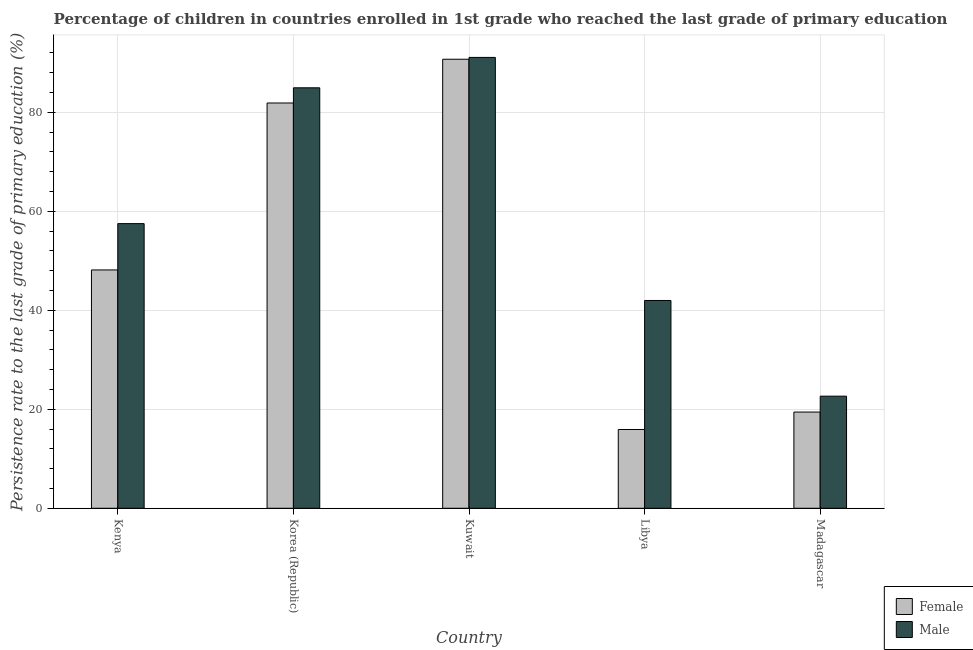Are the number of bars on each tick of the X-axis equal?
Your answer should be very brief. Yes. How many bars are there on the 2nd tick from the left?
Offer a very short reply. 2. What is the label of the 4th group of bars from the left?
Provide a succinct answer. Libya. What is the persistence rate of male students in Libya?
Provide a succinct answer. 41.99. Across all countries, what is the maximum persistence rate of female students?
Keep it short and to the point. 90.74. Across all countries, what is the minimum persistence rate of male students?
Ensure brevity in your answer.  22.65. In which country was the persistence rate of female students maximum?
Offer a terse response. Kuwait. In which country was the persistence rate of male students minimum?
Your answer should be compact. Madagascar. What is the total persistence rate of female students in the graph?
Offer a very short reply. 256.15. What is the difference between the persistence rate of female students in Kenya and that in Korea (Republic)?
Your response must be concise. -33.73. What is the difference between the persistence rate of female students in Madagascar and the persistence rate of male students in Korea (Republic)?
Make the answer very short. -65.52. What is the average persistence rate of male students per country?
Make the answer very short. 59.65. What is the difference between the persistence rate of female students and persistence rate of male students in Madagascar?
Your answer should be compact. -3.21. In how many countries, is the persistence rate of female students greater than 60 %?
Your answer should be very brief. 2. What is the ratio of the persistence rate of male students in Libya to that in Madagascar?
Make the answer very short. 1.85. Is the persistence rate of female students in Korea (Republic) less than that in Madagascar?
Your response must be concise. No. Is the difference between the persistence rate of male students in Kuwait and Madagascar greater than the difference between the persistence rate of female students in Kuwait and Madagascar?
Give a very brief answer. No. What is the difference between the highest and the second highest persistence rate of female students?
Make the answer very short. 8.84. What is the difference between the highest and the lowest persistence rate of male students?
Your answer should be compact. 68.45. In how many countries, is the persistence rate of male students greater than the average persistence rate of male students taken over all countries?
Your answer should be compact. 2. Is the sum of the persistence rate of male students in Korea (Republic) and Madagascar greater than the maximum persistence rate of female students across all countries?
Your answer should be compact. Yes. Are all the bars in the graph horizontal?
Your answer should be compact. No. Where does the legend appear in the graph?
Your answer should be compact. Bottom right. What is the title of the graph?
Keep it short and to the point. Percentage of children in countries enrolled in 1st grade who reached the last grade of primary education. Does "Travel Items" appear as one of the legend labels in the graph?
Give a very brief answer. No. What is the label or title of the X-axis?
Keep it short and to the point. Country. What is the label or title of the Y-axis?
Your answer should be very brief. Persistence rate to the last grade of primary education (%). What is the Persistence rate to the last grade of primary education (%) of Female in Kenya?
Provide a succinct answer. 48.16. What is the Persistence rate to the last grade of primary education (%) in Male in Kenya?
Keep it short and to the point. 57.52. What is the Persistence rate to the last grade of primary education (%) in Female in Korea (Republic)?
Your response must be concise. 81.89. What is the Persistence rate to the last grade of primary education (%) in Male in Korea (Republic)?
Provide a short and direct response. 84.96. What is the Persistence rate to the last grade of primary education (%) in Female in Kuwait?
Your answer should be compact. 90.74. What is the Persistence rate to the last grade of primary education (%) in Male in Kuwait?
Provide a succinct answer. 91.1. What is the Persistence rate to the last grade of primary education (%) in Female in Libya?
Your response must be concise. 15.92. What is the Persistence rate to the last grade of primary education (%) of Male in Libya?
Your answer should be very brief. 41.99. What is the Persistence rate to the last grade of primary education (%) of Female in Madagascar?
Provide a short and direct response. 19.44. What is the Persistence rate to the last grade of primary education (%) in Male in Madagascar?
Offer a terse response. 22.65. Across all countries, what is the maximum Persistence rate to the last grade of primary education (%) in Female?
Ensure brevity in your answer.  90.74. Across all countries, what is the maximum Persistence rate to the last grade of primary education (%) of Male?
Make the answer very short. 91.1. Across all countries, what is the minimum Persistence rate to the last grade of primary education (%) in Female?
Offer a very short reply. 15.92. Across all countries, what is the minimum Persistence rate to the last grade of primary education (%) in Male?
Provide a succinct answer. 22.65. What is the total Persistence rate to the last grade of primary education (%) of Female in the graph?
Offer a terse response. 256.15. What is the total Persistence rate to the last grade of primary education (%) in Male in the graph?
Ensure brevity in your answer.  298.23. What is the difference between the Persistence rate to the last grade of primary education (%) in Female in Kenya and that in Korea (Republic)?
Your answer should be very brief. -33.73. What is the difference between the Persistence rate to the last grade of primary education (%) of Male in Kenya and that in Korea (Republic)?
Provide a short and direct response. -27.44. What is the difference between the Persistence rate to the last grade of primary education (%) of Female in Kenya and that in Kuwait?
Keep it short and to the point. -42.58. What is the difference between the Persistence rate to the last grade of primary education (%) of Male in Kenya and that in Kuwait?
Offer a very short reply. -33.59. What is the difference between the Persistence rate to the last grade of primary education (%) in Female in Kenya and that in Libya?
Offer a terse response. 32.24. What is the difference between the Persistence rate to the last grade of primary education (%) of Male in Kenya and that in Libya?
Provide a short and direct response. 15.53. What is the difference between the Persistence rate to the last grade of primary education (%) in Female in Kenya and that in Madagascar?
Make the answer very short. 28.72. What is the difference between the Persistence rate to the last grade of primary education (%) of Male in Kenya and that in Madagascar?
Give a very brief answer. 34.86. What is the difference between the Persistence rate to the last grade of primary education (%) of Female in Korea (Republic) and that in Kuwait?
Offer a very short reply. -8.84. What is the difference between the Persistence rate to the last grade of primary education (%) of Male in Korea (Republic) and that in Kuwait?
Keep it short and to the point. -6.14. What is the difference between the Persistence rate to the last grade of primary education (%) in Female in Korea (Republic) and that in Libya?
Provide a succinct answer. 65.98. What is the difference between the Persistence rate to the last grade of primary education (%) of Male in Korea (Republic) and that in Libya?
Keep it short and to the point. 42.98. What is the difference between the Persistence rate to the last grade of primary education (%) of Female in Korea (Republic) and that in Madagascar?
Offer a very short reply. 62.45. What is the difference between the Persistence rate to the last grade of primary education (%) of Male in Korea (Republic) and that in Madagascar?
Give a very brief answer. 62.31. What is the difference between the Persistence rate to the last grade of primary education (%) in Female in Kuwait and that in Libya?
Your answer should be compact. 74.82. What is the difference between the Persistence rate to the last grade of primary education (%) of Male in Kuwait and that in Libya?
Give a very brief answer. 49.12. What is the difference between the Persistence rate to the last grade of primary education (%) of Female in Kuwait and that in Madagascar?
Provide a short and direct response. 71.29. What is the difference between the Persistence rate to the last grade of primary education (%) of Male in Kuwait and that in Madagascar?
Your answer should be very brief. 68.45. What is the difference between the Persistence rate to the last grade of primary education (%) of Female in Libya and that in Madagascar?
Keep it short and to the point. -3.52. What is the difference between the Persistence rate to the last grade of primary education (%) in Male in Libya and that in Madagascar?
Your answer should be compact. 19.33. What is the difference between the Persistence rate to the last grade of primary education (%) of Female in Kenya and the Persistence rate to the last grade of primary education (%) of Male in Korea (Republic)?
Give a very brief answer. -36.8. What is the difference between the Persistence rate to the last grade of primary education (%) in Female in Kenya and the Persistence rate to the last grade of primary education (%) in Male in Kuwait?
Provide a short and direct response. -42.94. What is the difference between the Persistence rate to the last grade of primary education (%) of Female in Kenya and the Persistence rate to the last grade of primary education (%) of Male in Libya?
Your answer should be compact. 6.17. What is the difference between the Persistence rate to the last grade of primary education (%) of Female in Kenya and the Persistence rate to the last grade of primary education (%) of Male in Madagascar?
Provide a succinct answer. 25.51. What is the difference between the Persistence rate to the last grade of primary education (%) of Female in Korea (Republic) and the Persistence rate to the last grade of primary education (%) of Male in Kuwait?
Your answer should be compact. -9.21. What is the difference between the Persistence rate to the last grade of primary education (%) of Female in Korea (Republic) and the Persistence rate to the last grade of primary education (%) of Male in Libya?
Your answer should be very brief. 39.91. What is the difference between the Persistence rate to the last grade of primary education (%) of Female in Korea (Republic) and the Persistence rate to the last grade of primary education (%) of Male in Madagascar?
Make the answer very short. 59.24. What is the difference between the Persistence rate to the last grade of primary education (%) in Female in Kuwait and the Persistence rate to the last grade of primary education (%) in Male in Libya?
Your answer should be compact. 48.75. What is the difference between the Persistence rate to the last grade of primary education (%) of Female in Kuwait and the Persistence rate to the last grade of primary education (%) of Male in Madagascar?
Ensure brevity in your answer.  68.08. What is the difference between the Persistence rate to the last grade of primary education (%) of Female in Libya and the Persistence rate to the last grade of primary education (%) of Male in Madagascar?
Give a very brief answer. -6.74. What is the average Persistence rate to the last grade of primary education (%) of Female per country?
Give a very brief answer. 51.23. What is the average Persistence rate to the last grade of primary education (%) of Male per country?
Offer a very short reply. 59.65. What is the difference between the Persistence rate to the last grade of primary education (%) of Female and Persistence rate to the last grade of primary education (%) of Male in Kenya?
Offer a very short reply. -9.36. What is the difference between the Persistence rate to the last grade of primary education (%) of Female and Persistence rate to the last grade of primary education (%) of Male in Korea (Republic)?
Your response must be concise. -3.07. What is the difference between the Persistence rate to the last grade of primary education (%) of Female and Persistence rate to the last grade of primary education (%) of Male in Kuwait?
Make the answer very short. -0.37. What is the difference between the Persistence rate to the last grade of primary education (%) in Female and Persistence rate to the last grade of primary education (%) in Male in Libya?
Make the answer very short. -26.07. What is the difference between the Persistence rate to the last grade of primary education (%) in Female and Persistence rate to the last grade of primary education (%) in Male in Madagascar?
Your answer should be very brief. -3.21. What is the ratio of the Persistence rate to the last grade of primary education (%) of Female in Kenya to that in Korea (Republic)?
Give a very brief answer. 0.59. What is the ratio of the Persistence rate to the last grade of primary education (%) in Male in Kenya to that in Korea (Republic)?
Your response must be concise. 0.68. What is the ratio of the Persistence rate to the last grade of primary education (%) in Female in Kenya to that in Kuwait?
Your answer should be very brief. 0.53. What is the ratio of the Persistence rate to the last grade of primary education (%) in Male in Kenya to that in Kuwait?
Your answer should be compact. 0.63. What is the ratio of the Persistence rate to the last grade of primary education (%) of Female in Kenya to that in Libya?
Offer a terse response. 3.03. What is the ratio of the Persistence rate to the last grade of primary education (%) in Male in Kenya to that in Libya?
Your answer should be compact. 1.37. What is the ratio of the Persistence rate to the last grade of primary education (%) in Female in Kenya to that in Madagascar?
Provide a short and direct response. 2.48. What is the ratio of the Persistence rate to the last grade of primary education (%) in Male in Kenya to that in Madagascar?
Offer a terse response. 2.54. What is the ratio of the Persistence rate to the last grade of primary education (%) of Female in Korea (Republic) to that in Kuwait?
Keep it short and to the point. 0.9. What is the ratio of the Persistence rate to the last grade of primary education (%) in Male in Korea (Republic) to that in Kuwait?
Make the answer very short. 0.93. What is the ratio of the Persistence rate to the last grade of primary education (%) in Female in Korea (Republic) to that in Libya?
Provide a succinct answer. 5.14. What is the ratio of the Persistence rate to the last grade of primary education (%) of Male in Korea (Republic) to that in Libya?
Provide a succinct answer. 2.02. What is the ratio of the Persistence rate to the last grade of primary education (%) of Female in Korea (Republic) to that in Madagascar?
Your answer should be compact. 4.21. What is the ratio of the Persistence rate to the last grade of primary education (%) in Male in Korea (Republic) to that in Madagascar?
Your answer should be very brief. 3.75. What is the ratio of the Persistence rate to the last grade of primary education (%) of Female in Kuwait to that in Libya?
Your answer should be very brief. 5.7. What is the ratio of the Persistence rate to the last grade of primary education (%) in Male in Kuwait to that in Libya?
Your answer should be compact. 2.17. What is the ratio of the Persistence rate to the last grade of primary education (%) of Female in Kuwait to that in Madagascar?
Your answer should be compact. 4.67. What is the ratio of the Persistence rate to the last grade of primary education (%) of Male in Kuwait to that in Madagascar?
Your answer should be very brief. 4.02. What is the ratio of the Persistence rate to the last grade of primary education (%) of Female in Libya to that in Madagascar?
Give a very brief answer. 0.82. What is the ratio of the Persistence rate to the last grade of primary education (%) in Male in Libya to that in Madagascar?
Offer a terse response. 1.85. What is the difference between the highest and the second highest Persistence rate to the last grade of primary education (%) in Female?
Give a very brief answer. 8.84. What is the difference between the highest and the second highest Persistence rate to the last grade of primary education (%) of Male?
Give a very brief answer. 6.14. What is the difference between the highest and the lowest Persistence rate to the last grade of primary education (%) of Female?
Provide a short and direct response. 74.82. What is the difference between the highest and the lowest Persistence rate to the last grade of primary education (%) in Male?
Provide a short and direct response. 68.45. 